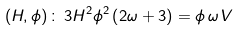Convert formula to latex. <formula><loc_0><loc_0><loc_500><loc_500>\left ( H , \phi \right ) \colon \, 3 H ^ { 2 } \phi ^ { 2 } \left ( 2 \omega + 3 \right ) = \phi \, \omega \, V</formula> 